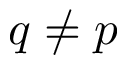<formula> <loc_0><loc_0><loc_500><loc_500>q \neq p</formula> 